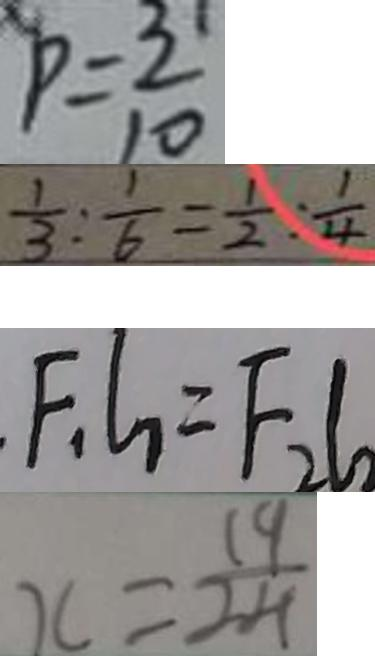Convert formula to latex. <formula><loc_0><loc_0><loc_500><loc_500>p = \frac { 3 } { 1 0 } 
 \frac { 1 } { 3 } : \frac { 1 } { 6 } = \frac { 1 } { 2 } : \frac { 1 } { 4 } 
 F _ { 1 } l _ { 1 } = F _ { 2 } l _ { 2 } 
 x = \frac { 1 9 } { 2 4 }</formula> 